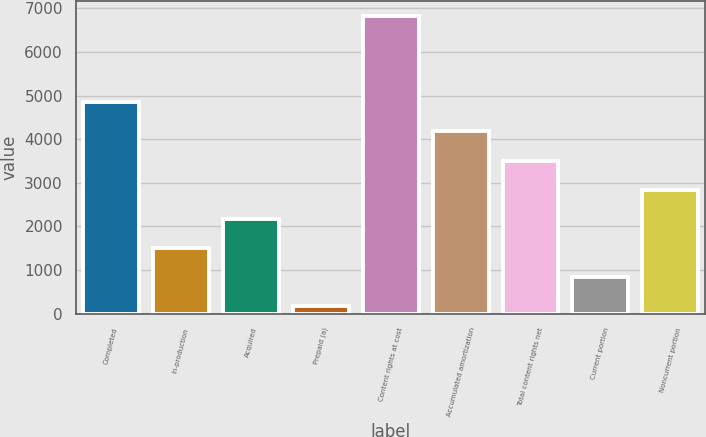<chart> <loc_0><loc_0><loc_500><loc_500><bar_chart><fcel>Completed<fcel>In-production<fcel>Acquired<fcel>Prepaid (a)<fcel>Content rights at cost<fcel>Accumulated amortization<fcel>Total content rights net<fcel>Current portion<fcel>Noncurrent portion<nl><fcel>4860.9<fcel>1508.8<fcel>2172.7<fcel>181<fcel>6820<fcel>4197<fcel>3500.5<fcel>844.9<fcel>2836.6<nl></chart> 